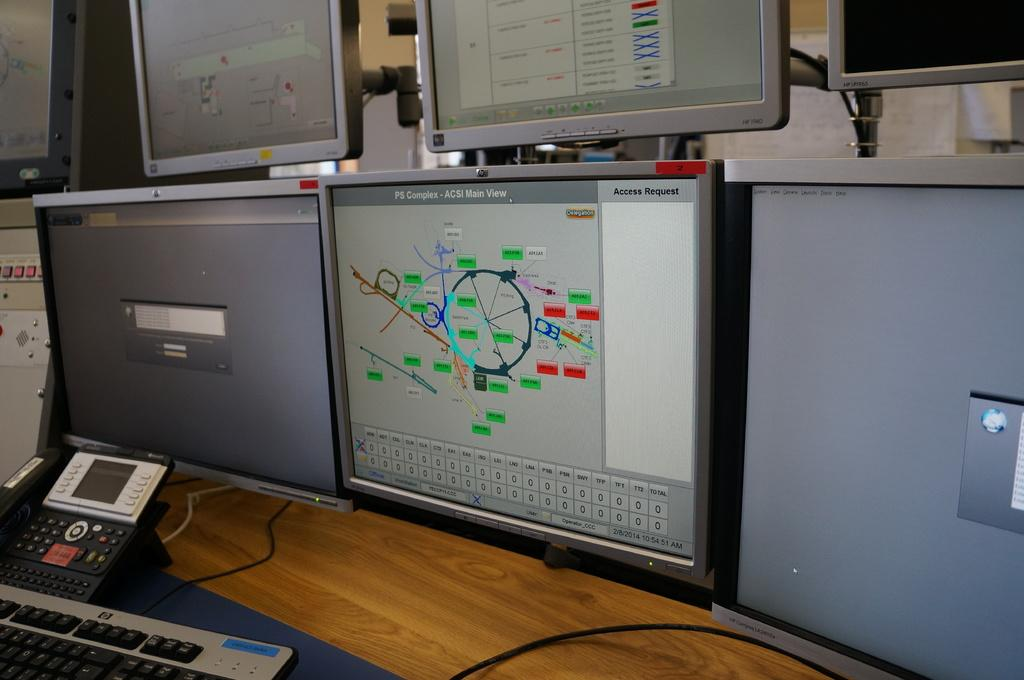<image>
Provide a brief description of the given image. Many screens on top of a table with one screen saying PS Complex. 